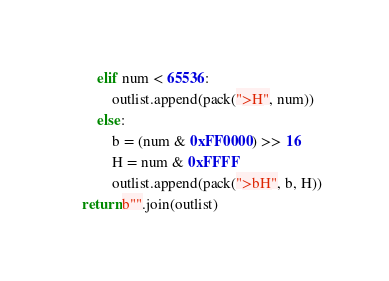<code> <loc_0><loc_0><loc_500><loc_500><_Python_>        elif num < 65536:
            outlist.append(pack(">H", num))
        else:
            b = (num & 0xFF0000) >> 16
            H = num & 0xFFFF
            outlist.append(pack(">bH", b, H))
    return b"".join(outlist)
</code> 